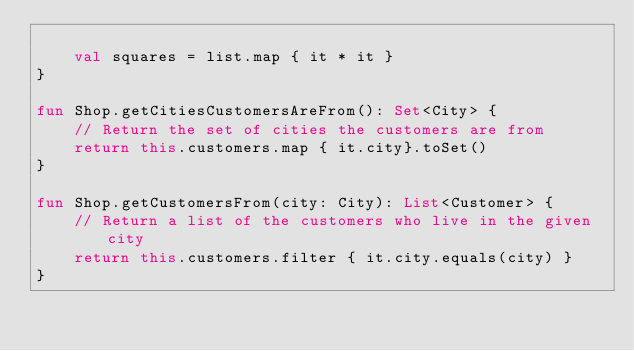Convert code to text. <code><loc_0><loc_0><loc_500><loc_500><_Kotlin_>
    val squares = list.map { it * it }
}

fun Shop.getCitiesCustomersAreFrom(): Set<City> {
    // Return the set of cities the customers are from
    return this.customers.map { it.city}.toSet()
}

fun Shop.getCustomersFrom(city: City): List<Customer> {
    // Return a list of the customers who live in the given city
    return this.customers.filter { it.city.equals(city) }
}


</code> 